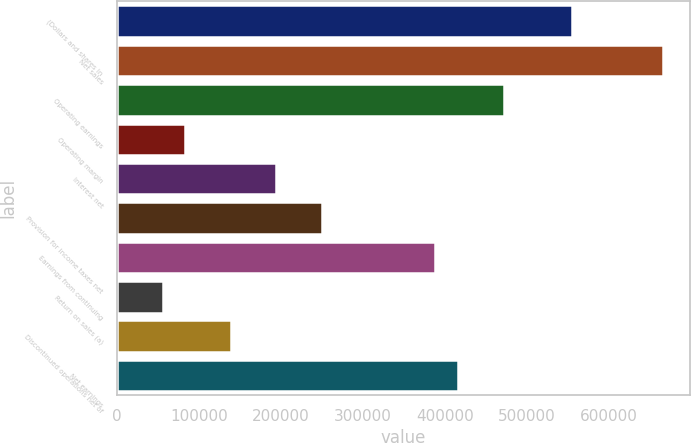<chart> <loc_0><loc_0><loc_500><loc_500><bar_chart><fcel>(Dollars and shares in<fcel>Net sales<fcel>Operating earnings<fcel>Operating margin<fcel>Interest net<fcel>Provision for income taxes net<fcel>Earnings from continuing<fcel>Return on sales (a)<fcel>Discontinued operations net of<fcel>Net earnings<nl><fcel>555399<fcel>666479<fcel>472090<fcel>83310.5<fcel>194390<fcel>249930<fcel>388780<fcel>55540.5<fcel>138850<fcel>416550<nl></chart> 